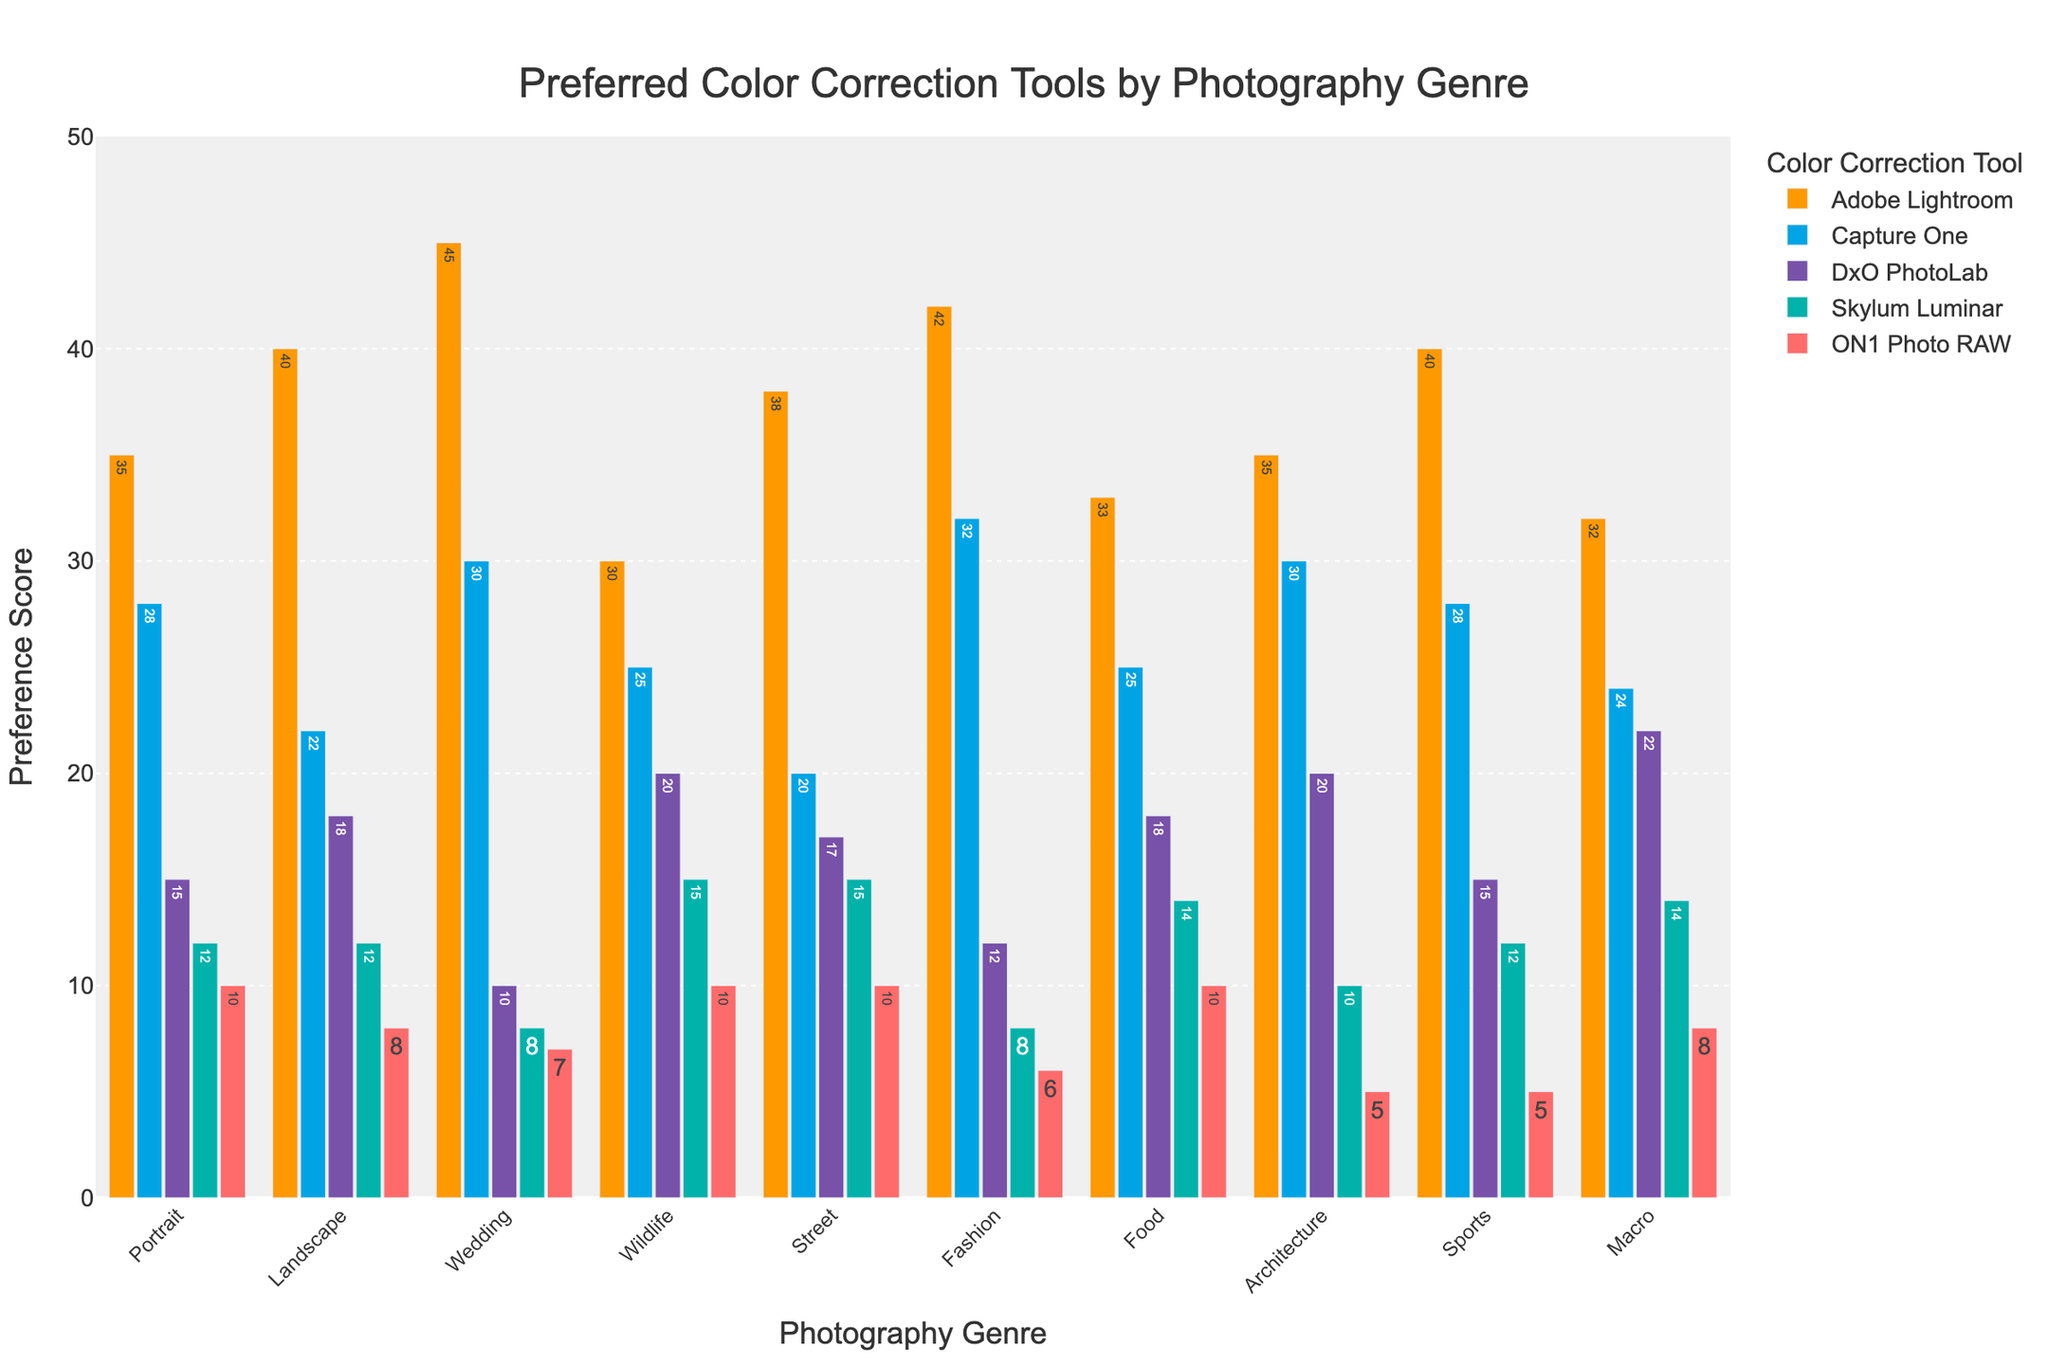Which genre has the highest preference score for Adobe Lightroom? Look at the bars for Adobe Lightroom across all genres. The Wedding genre has the tallest bar, indicating the highest preference score.
Answer: Wedding Which tool is the least preferred for the Landscape genre? Compare the heights of the bars for the Landscape genre. ON1 Photo RAW has the shortest bar, indicating the lowest preference score.
Answer: ON1 Photo RAW How many more people prefer Adobe Lightroom over DxO PhotoLab in the Portrait genre? Subtract the preference score of DxO PhotoLab from Adobe Lightroom in the Portrait genre: 35 - 15 = 20.
Answer: 20 Which genre has the same preference score for Skylum Luminar and ON1 Photo RAW? Look for bars of Skylum Luminar and ON1 Photo RAW that have the same height across genres. Both have a score of 12 in the Portrait genre.
Answer: Portrait What is the average preference score for Capture One across all genres? Add all the preference scores for Capture One and divide by the number of genres: (28 + 22 + 30 + 25 + 20 + 32 + 25 + 30 + 28 + 24) / 10 = 26.4.
Answer: 26.4 In which genre is Capture One preferred more than Adobe Lightroom? Compare the bars of Capture One and Adobe Lightroom for each genre. Capture One is never preferred more than Adobe Lightroom in any genre.
Answer: None Which tool is preferred exactly twice as much in the Wedding genre compared to the Sports genre? Look for a tool where the preference score in the Wedding genre is exactly twice that in the Sports genre. Adobe Lightroom has a score of 45 in the Wedding genre and 40 in the Sports genre, which doesn't match. But Capture One has 30 in Wedding and 15 in Sports, which is not correct either. This was a trick question — none match the criteria.
Answer: None What is the total preference score for DxO PhotoLab across Portrait, Landscape, and Wildlife genres? Add the preference scores for DxO PhotoLab in these genres: 15 (Portrait) + 18 (Landscape) + 20 (Wildlife) = 53.
Answer: 53 How do the preference scores for Adobe Lightroom compare between the Fashion and Food genres? Compare the heights of the bars for Adobe Lightroom between Fashion and Food genres. Fashion has a score of 42, and Food has a score of 33. Fashion has a higher preference score.
Answer: Fashion is higher Which two genres have the highest combined preference scores for ON1 Photo RAW? Add the preference scores for ON1 Photo RAW across all genres and identify the top two sums: Portrait (10), Landscape (8), Wedding (7), Wildlife (10), Street (10), Fashion (6), Food (10), Architecture (5), Sports (5), and Macro (8). The highest combined scores come from Street (10) and Food (10).
Answer: Street and Food 